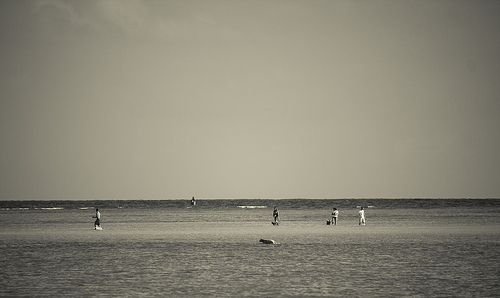[0.13, 0.7, 0.93, 0.79]. This large expanse captures the sandy beach terrain, a characteristic feature reflecting sunlight and hosting the footprints of beachgoers. 